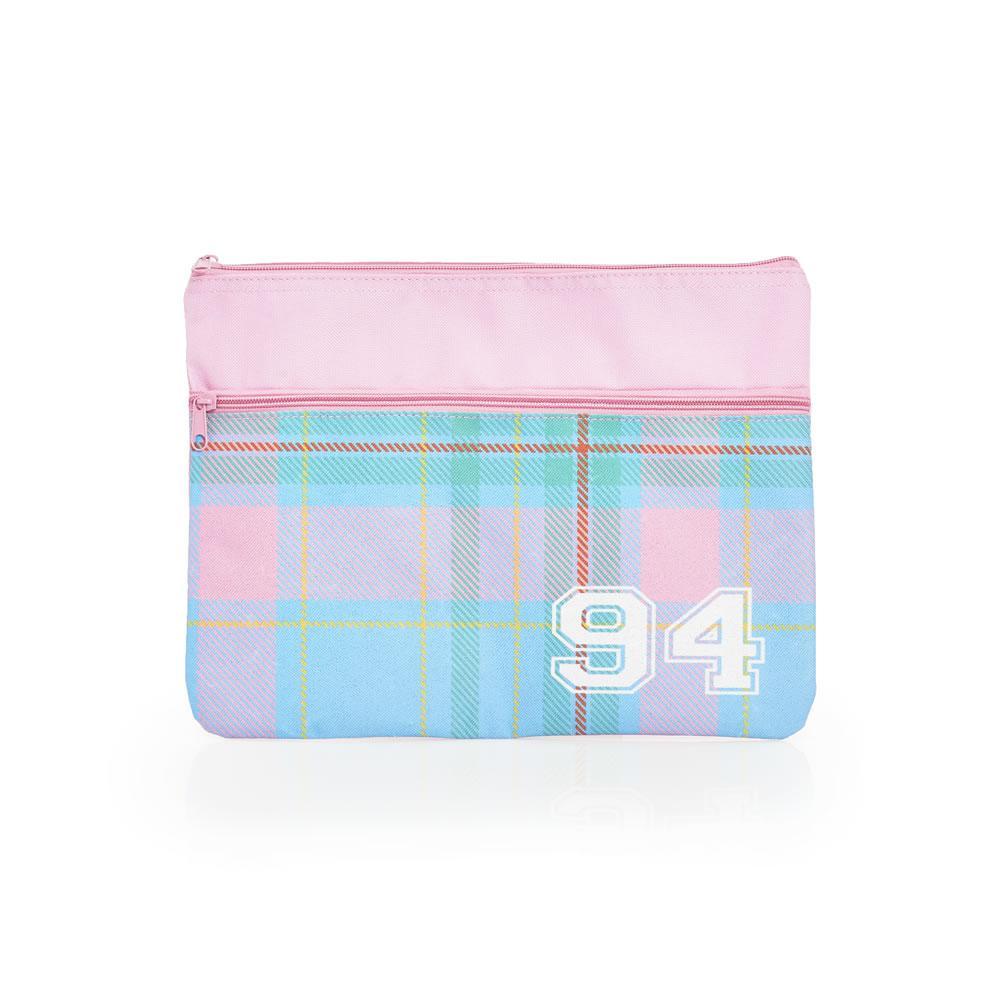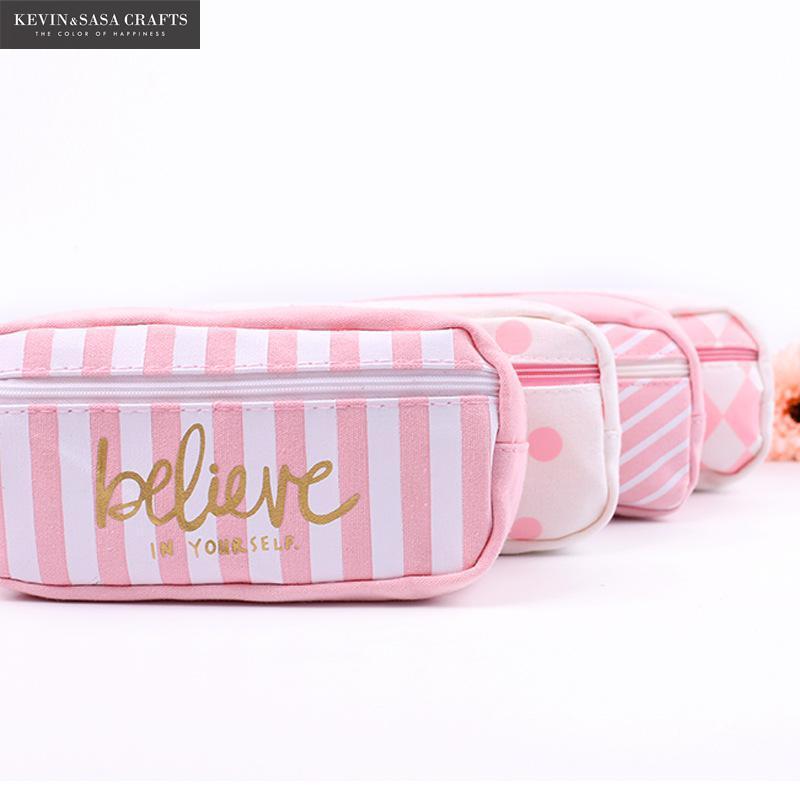The first image is the image on the left, the second image is the image on the right. Assess this claim about the two images: "One photo contains three or more pencil cases.". Correct or not? Answer yes or no. Yes. The first image is the image on the left, the second image is the image on the right. Given the left and right images, does the statement "An image shows a grouping of at least three pencil cases of the same size." hold true? Answer yes or no. Yes. 